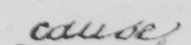Please transcribe the handwritten text in this image. cause 